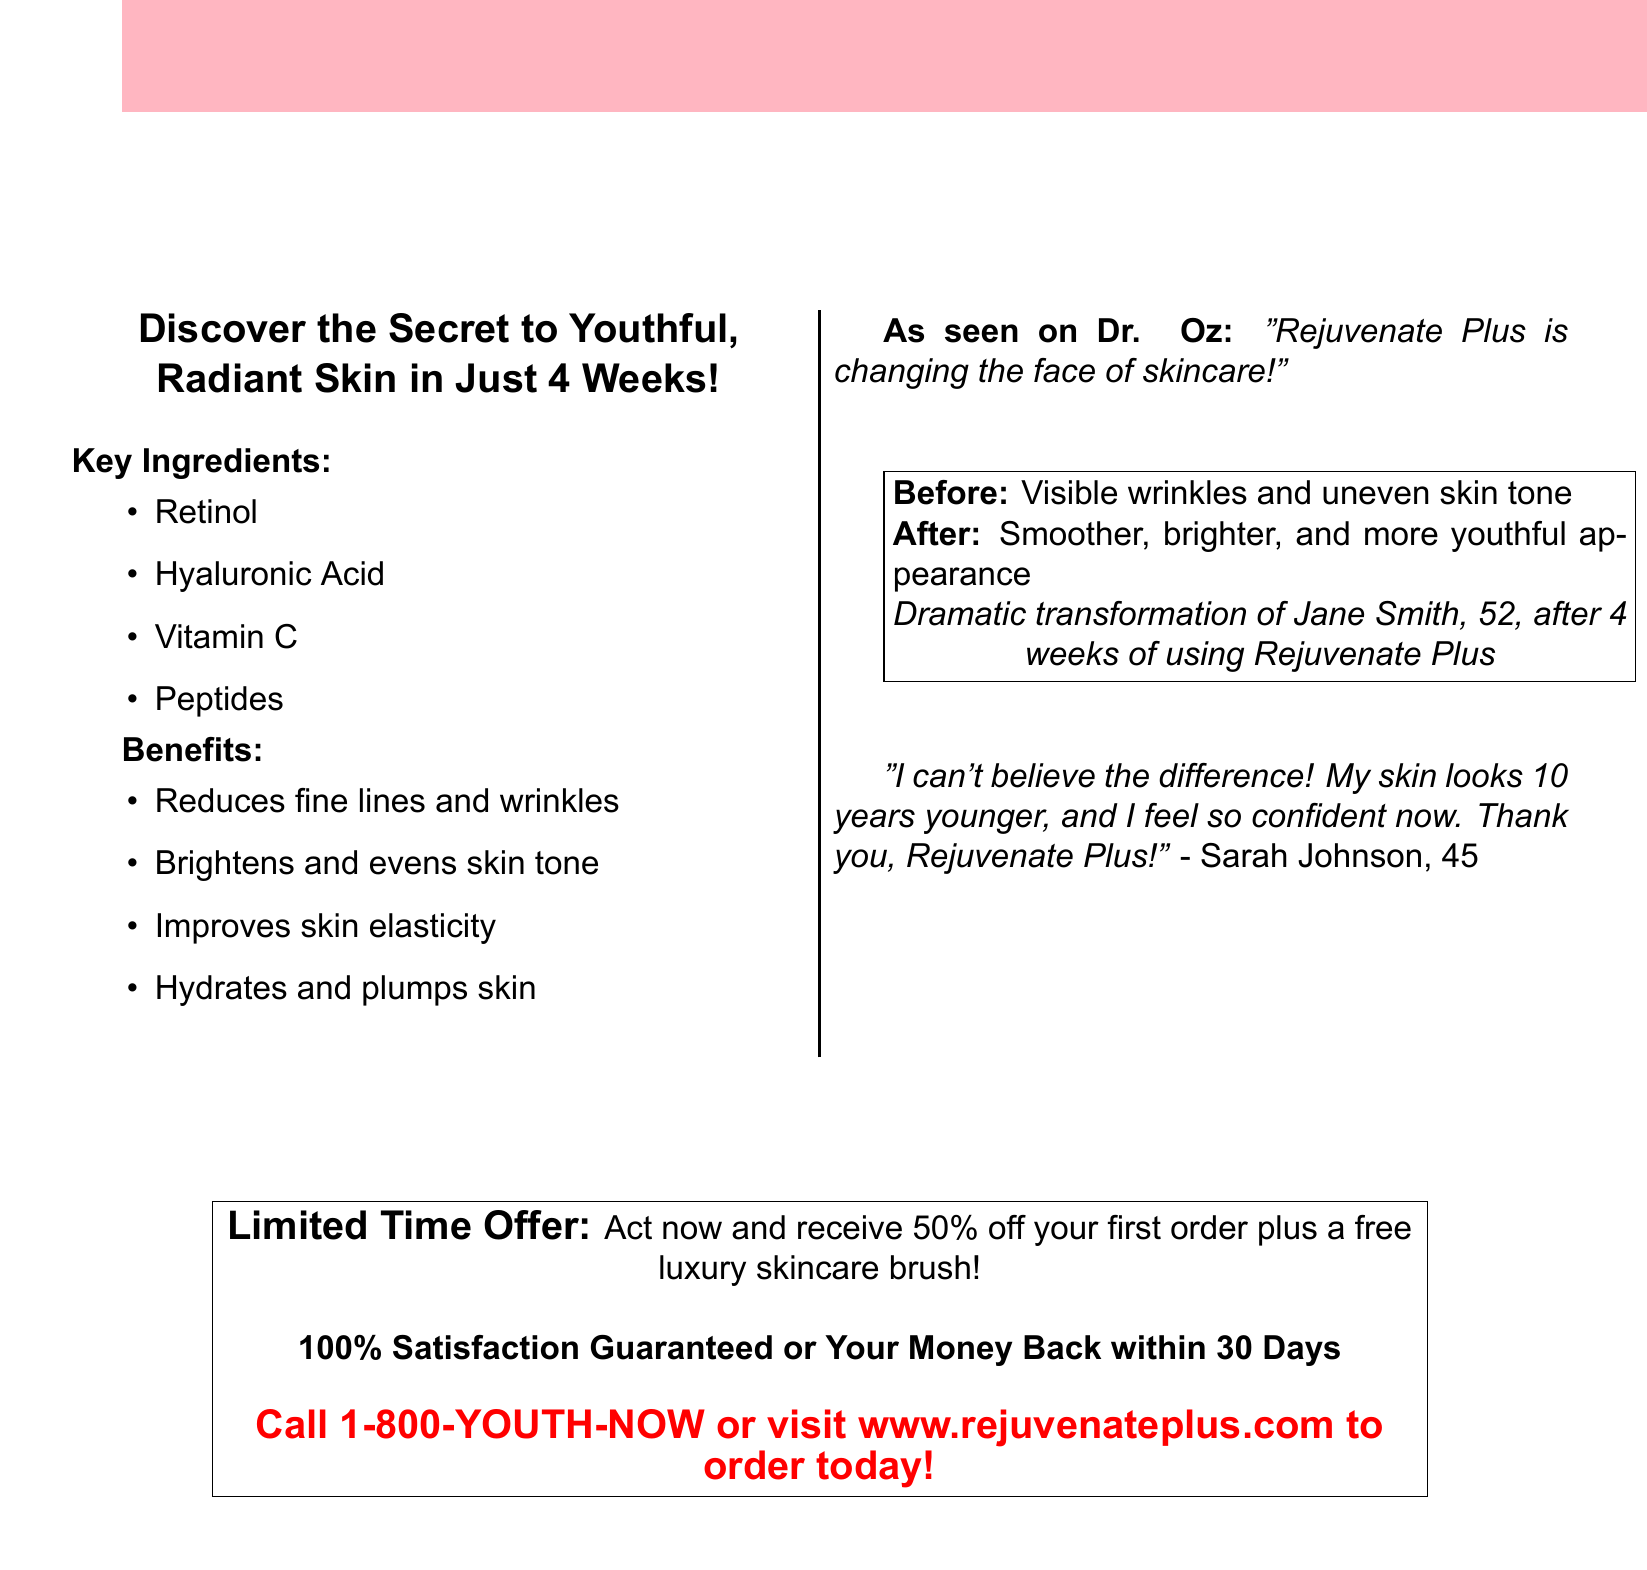What is the product name? The product name is mentioned in the headline of the document.
Answer: Rejuvenate Plus What are the key ingredients? The key ingredients list appears immediately after the introduction.
Answer: Retinol, Hyaluronic Acid, Vitamin C, Peptides What is the limited-time offer? The limited-time offer is highlighted in a box in the document.
Answer: 50% off your first order plus a free luxury skincare brush Who endorsed the product? The endorsement is provided in the document by a well-known figure.
Answer: Dr. Oz What transformation is shown in the before-and-after photo? The description of the photo outlines the changes observed after using the product.
Answer: Smoother, brighter, and more youthful appearance How long does it take to see results? The time frame for visible results is stated in the subheadline.
Answer: 4 Weeks What guarantee is offered? The type of guarantee provided is mentioned towards the end of the document.
Answer: 100% Satisfaction Guaranteed or Your Money Back within 30 Days What is the customer testimonial about? The testimonial shares the personal experience of a customer regarding the product.
Answer: Skin looks 10 years younger What is the call to action? The call to action is clearly stated in a prominent section of the document.
Answer: Call 1-800-YOUTH-NOW or visit www.rejuvenateplus.com to order today! 